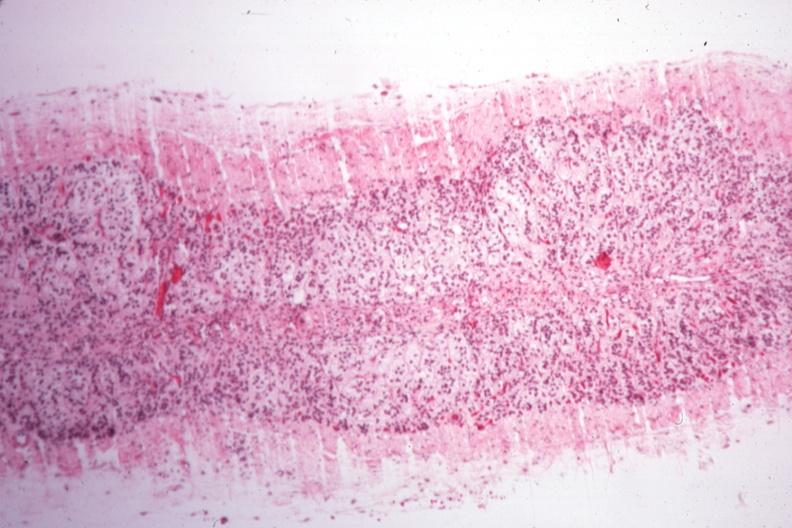s very good example present?
Answer the question using a single word or phrase. No 